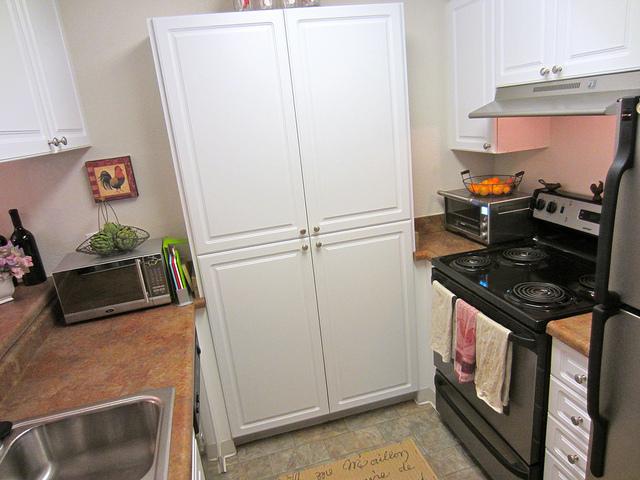What room of the house is this?
Answer briefly. Kitchen. Is there an old ice box in the picture?
Write a very short answer. No. Is this stove electric?
Give a very brief answer. Yes. What is behind the closed doors?
Quick response, please. Food. Where is the pink light eliminating from?
Be succinct. Stove hood. 